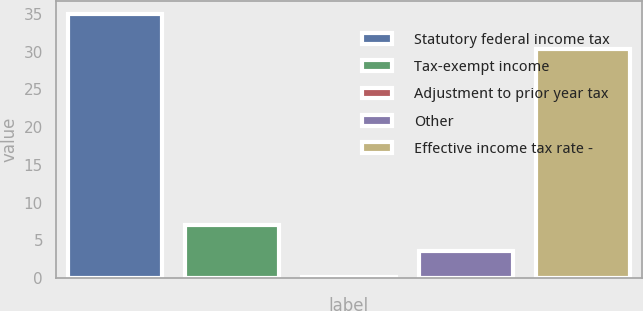Convert chart to OTSL. <chart><loc_0><loc_0><loc_500><loc_500><bar_chart><fcel>Statutory federal income tax<fcel>Tax-exempt income<fcel>Adjustment to prior year tax<fcel>Other<fcel>Effective income tax rate -<nl><fcel>35<fcel>7.08<fcel>0.1<fcel>3.59<fcel>30.3<nl></chart> 